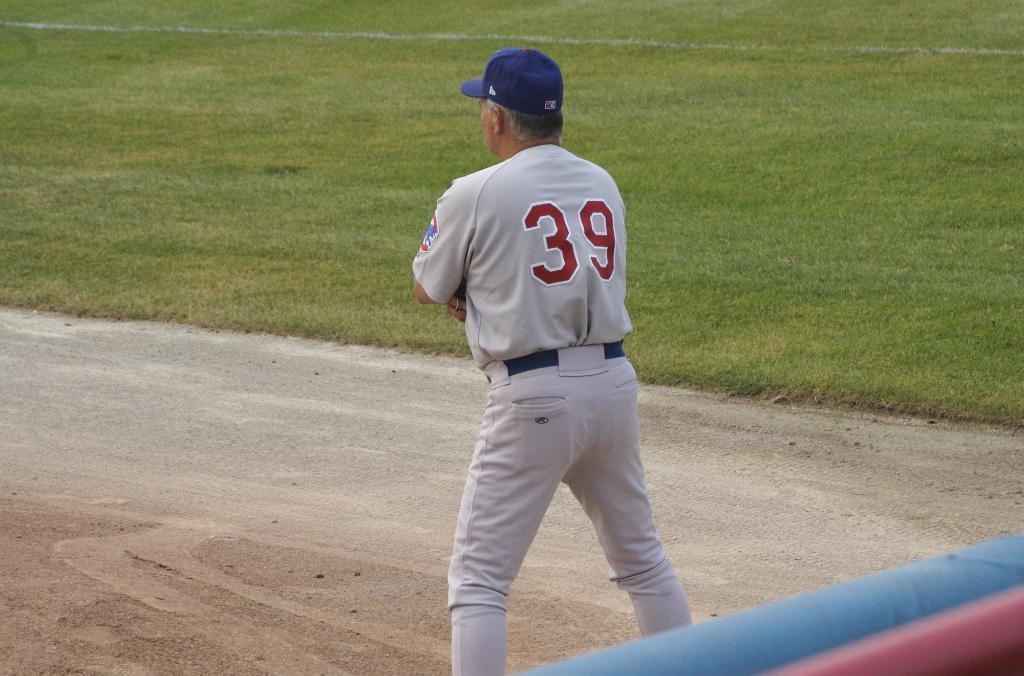Please provide a concise description of this image. In this picture I can see there is a man standing and he is wearing a shirt, cap and a pant. In the backdrop there is grass. 